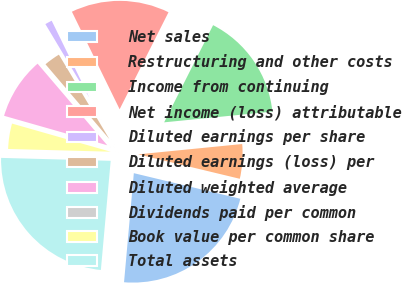Convert chart. <chart><loc_0><loc_0><loc_500><loc_500><pie_chart><fcel>Net sales<fcel>Restructuring and other costs<fcel>Income from continuing<fcel>Net income (loss) attributable<fcel>Diluted earnings per share<fcel>Diluted earnings (loss) per<fcel>Diluted weighted average<fcel>Dividends paid per common<fcel>Book value per common share<fcel>Total assets<nl><fcel>22.67%<fcel>5.33%<fcel>16.0%<fcel>14.67%<fcel>1.33%<fcel>2.67%<fcel>9.33%<fcel>0.0%<fcel>4.0%<fcel>24.0%<nl></chart> 